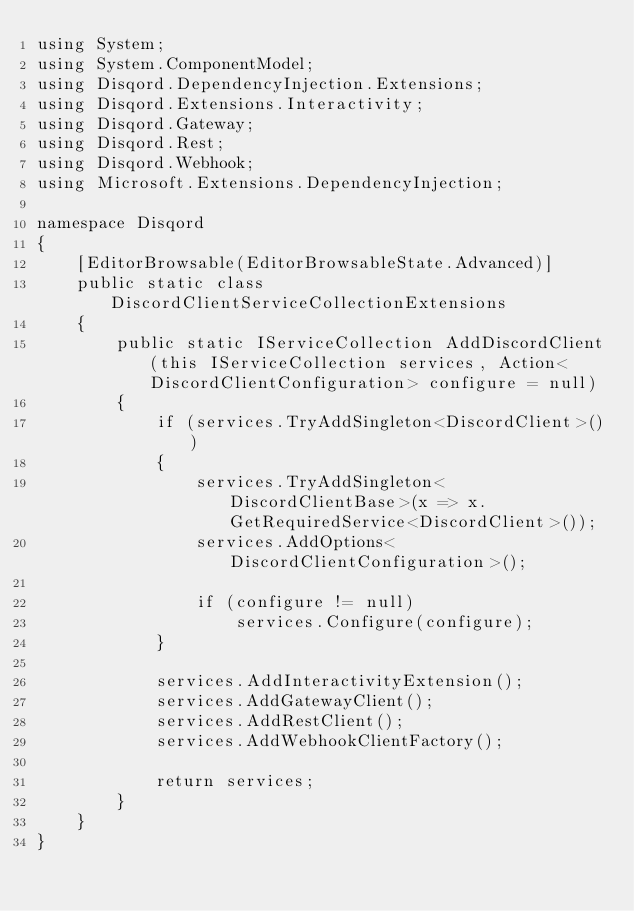<code> <loc_0><loc_0><loc_500><loc_500><_C#_>using System;
using System.ComponentModel;
using Disqord.DependencyInjection.Extensions;
using Disqord.Extensions.Interactivity;
using Disqord.Gateway;
using Disqord.Rest;
using Disqord.Webhook;
using Microsoft.Extensions.DependencyInjection;

namespace Disqord
{
    [EditorBrowsable(EditorBrowsableState.Advanced)]
    public static class DiscordClientServiceCollectionExtensions
    {
        public static IServiceCollection AddDiscordClient(this IServiceCollection services, Action<DiscordClientConfiguration> configure = null)
        {
            if (services.TryAddSingleton<DiscordClient>())
            {
                services.TryAddSingleton<DiscordClientBase>(x => x.GetRequiredService<DiscordClient>());
                services.AddOptions<DiscordClientConfiguration>();

                if (configure != null)
                    services.Configure(configure);
            }

            services.AddInteractivityExtension();
            services.AddGatewayClient();
            services.AddRestClient();
            services.AddWebhookClientFactory();

            return services;
        }
    }
}
</code> 